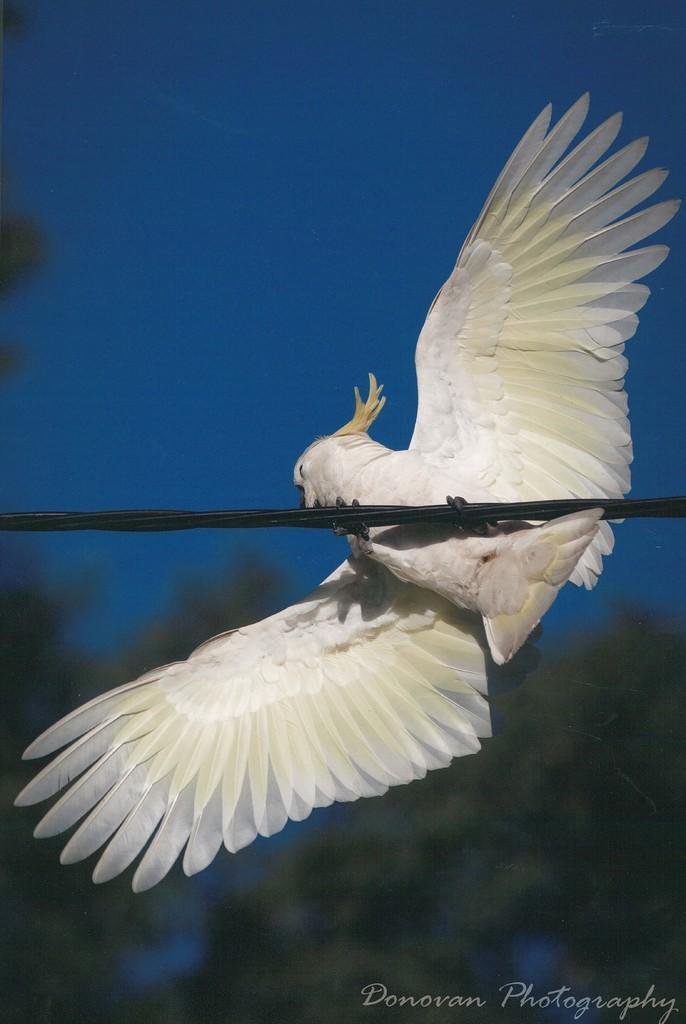In one or two sentences, can you explain what this image depicts? There is a white bird on a wire. In the background it is blurred. In the right bottom corner there is a watermark. 